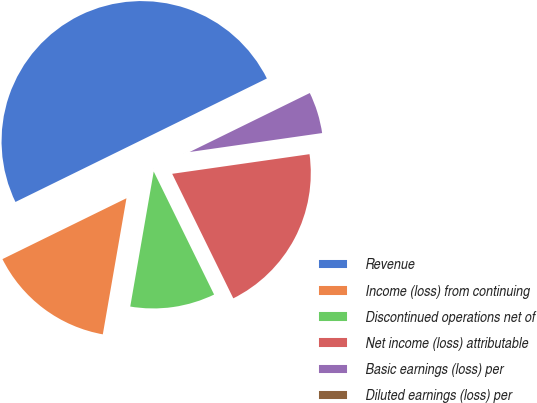<chart> <loc_0><loc_0><loc_500><loc_500><pie_chart><fcel>Revenue<fcel>Income (loss) from continuing<fcel>Discontinued operations net of<fcel>Net income (loss) attributable<fcel>Basic earnings (loss) per<fcel>Diluted earnings (loss) per<nl><fcel>49.99%<fcel>15.0%<fcel>10.0%<fcel>20.0%<fcel>5.0%<fcel>0.01%<nl></chart> 